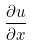<formula> <loc_0><loc_0><loc_500><loc_500>\frac { \partial u } { \partial x }</formula> 